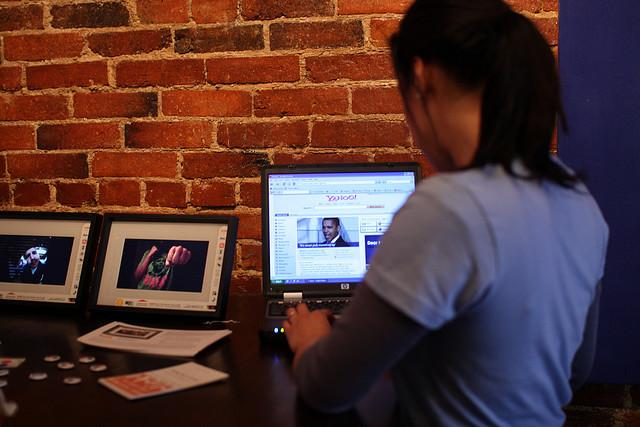In what year did the website on her screen become a company? 1994 